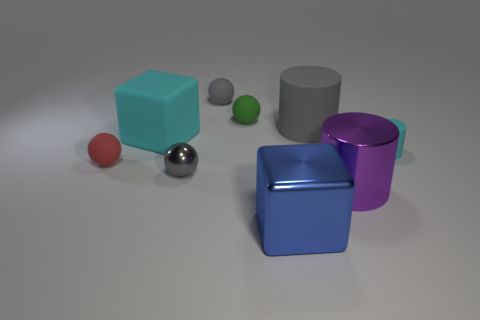What shapes and colors are present in this image? The image includes a variety of geometric shapes: there are two cylinders, one gray and one purple; two cubes, one blue and one teal; a small red sphere; a small green cylinder; and a silver sphere. 